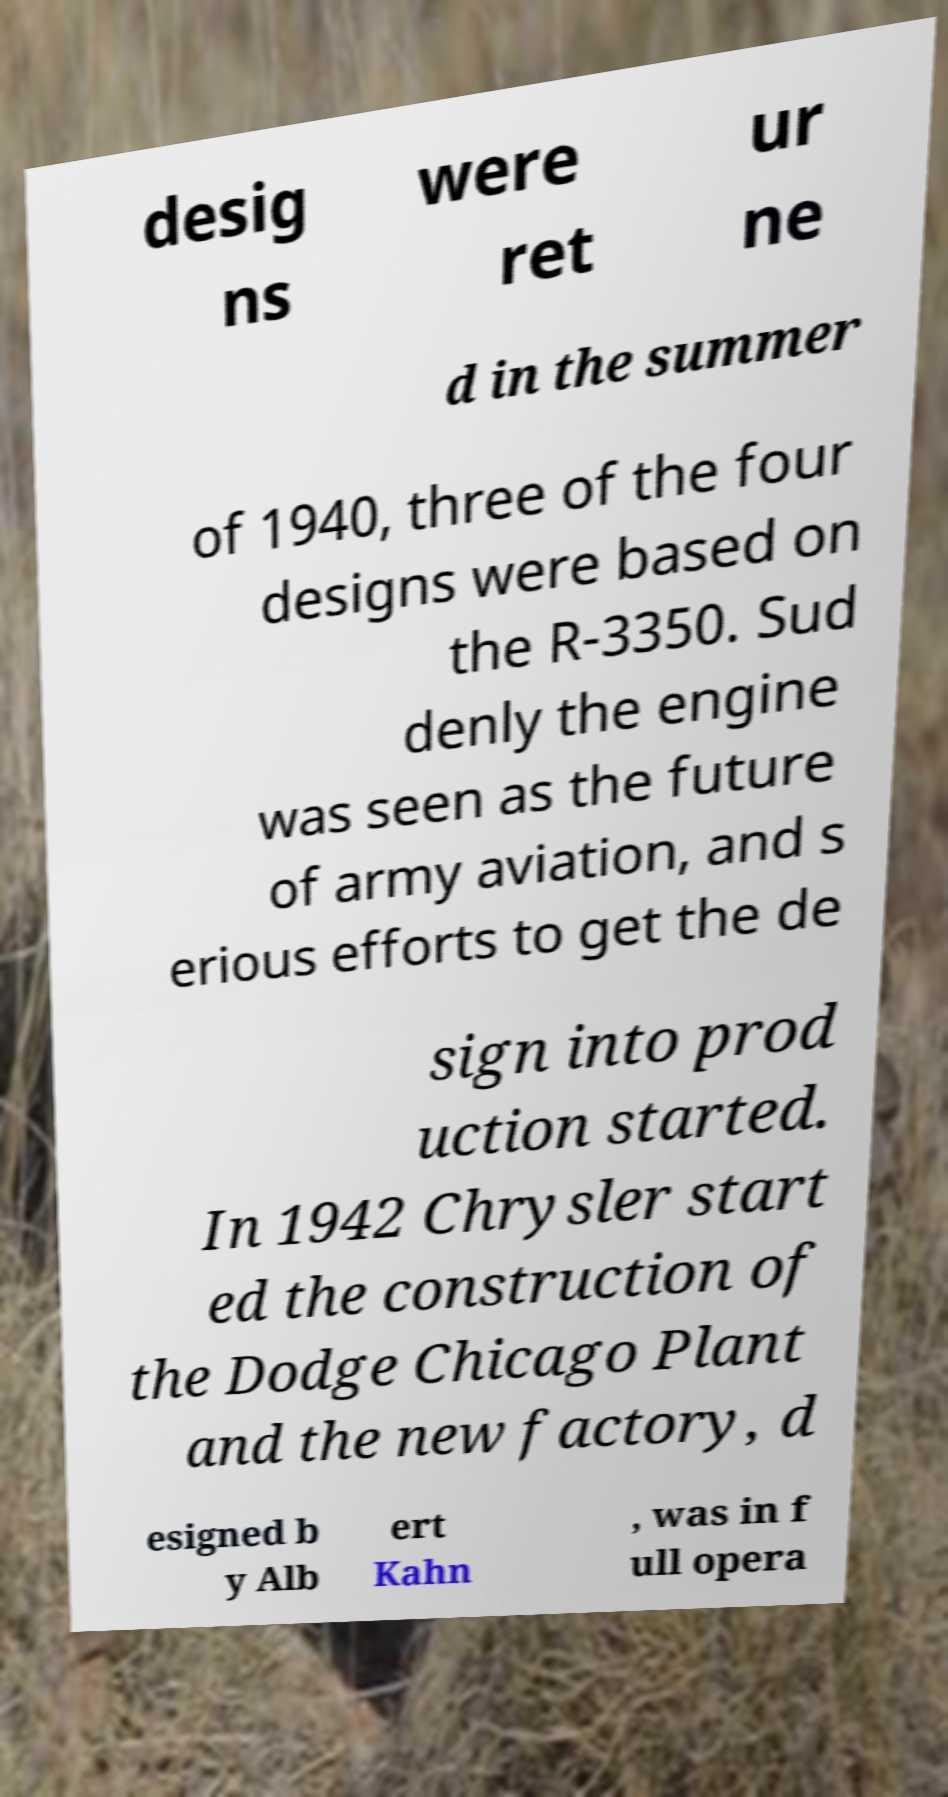There's text embedded in this image that I need extracted. Can you transcribe it verbatim? desig ns were ret ur ne d in the summer of 1940, three of the four designs were based on the R-3350. Sud denly the engine was seen as the future of army aviation, and s erious efforts to get the de sign into prod uction started. In 1942 Chrysler start ed the construction of the Dodge Chicago Plant and the new factory, d esigned b y Alb ert Kahn , was in f ull opera 